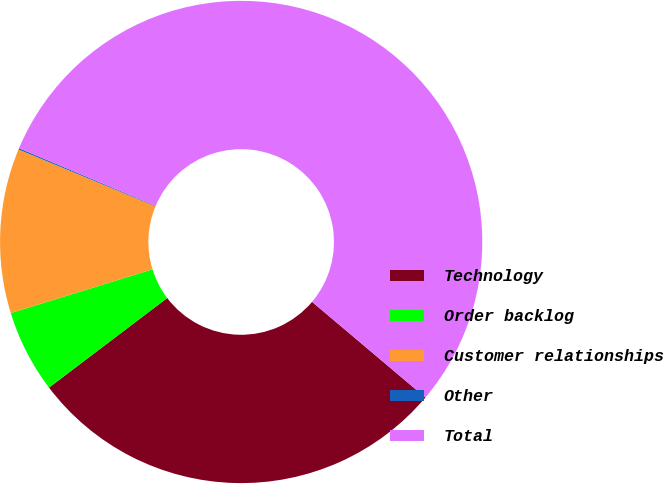Convert chart. <chart><loc_0><loc_0><loc_500><loc_500><pie_chart><fcel>Technology<fcel>Order backlog<fcel>Customer relationships<fcel>Other<fcel>Total<nl><fcel>28.52%<fcel>5.56%<fcel>11.03%<fcel>0.09%<fcel>54.8%<nl></chart> 